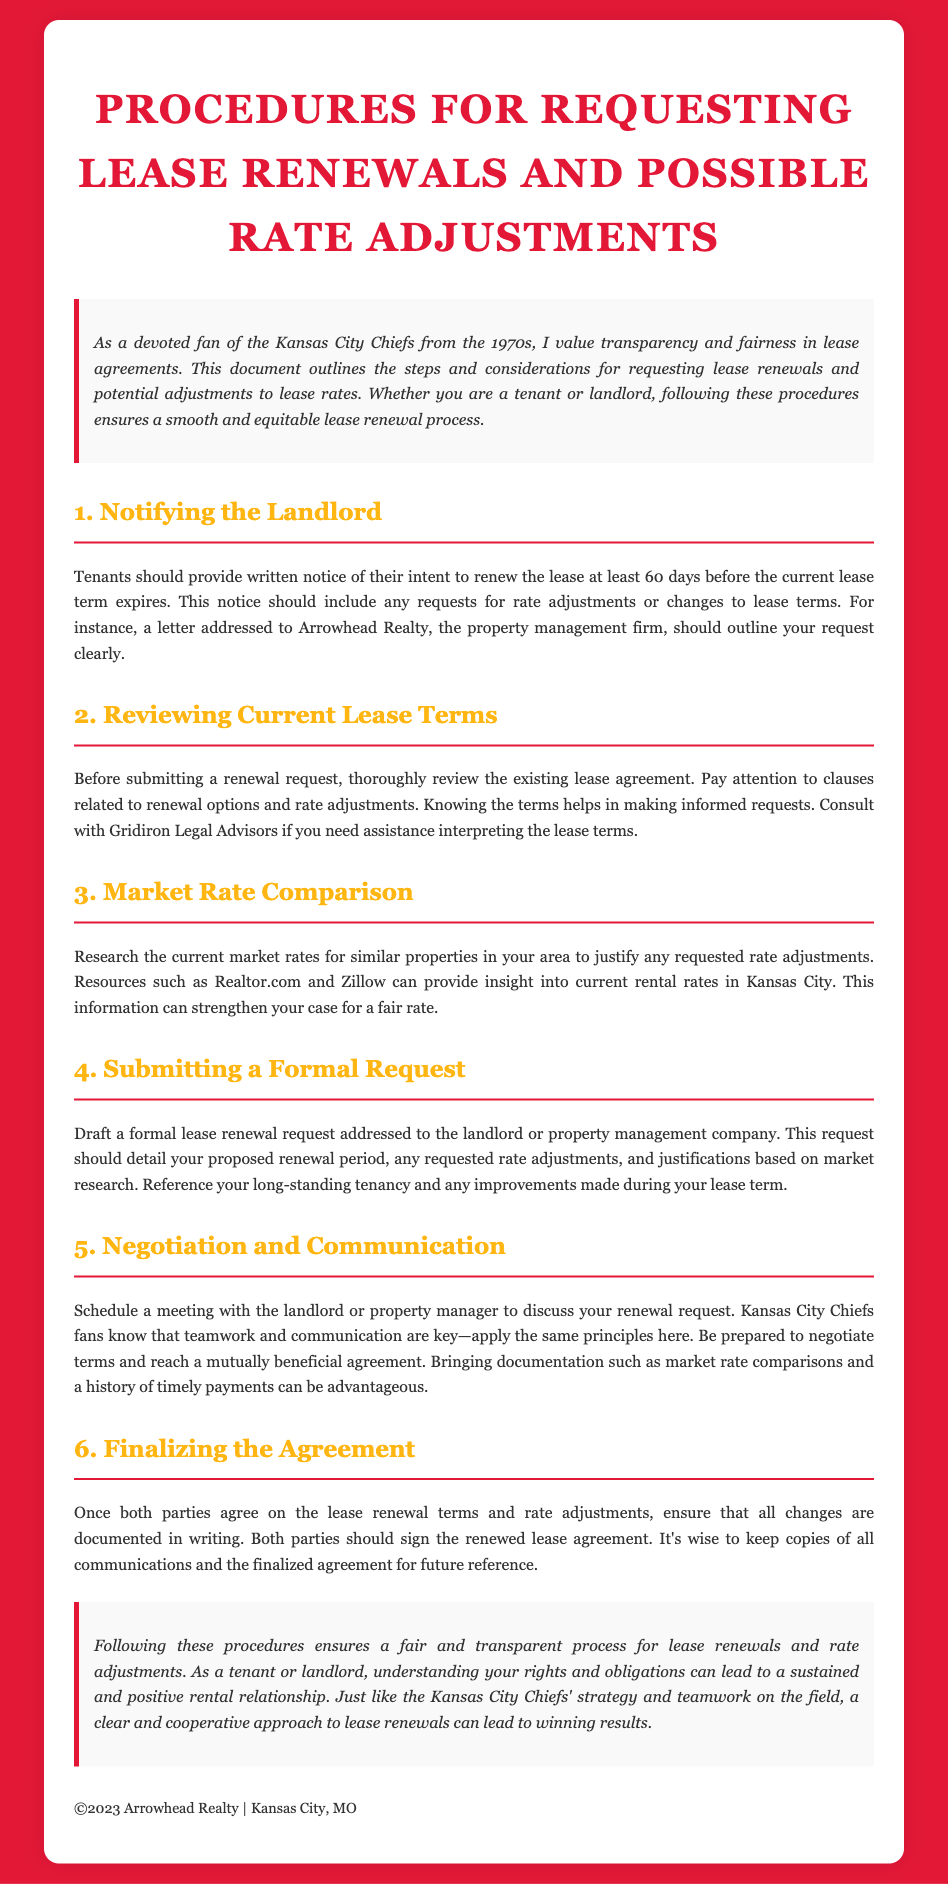What is the written notice period for lease renewal? Tenants must provide written notice of their intent to renew at least 60 days before the lease expires.
Answer: 60 days Who should the renewal request be addressed to? The renewal request should be directed to Arrowhead Realty, the property management firm.
Answer: Arrowhead Realty What should be included in the renewal request? The formal lease renewal request should detail the proposed renewal period and any requested rate adjustments based on market research.
Answer: Proposed renewal period and rate adjustments What is a key step before submitting a renewal request? Reviewing the existing lease agreement thoroughly is essential before making any renewal requests.
Answer: Reviewing the existing lease agreement What is advised to bring to the negotiation meeting? Bringing documentation such as market rate comparisons and a history of timely payments can be advantageous during the negotiation.
Answer: Market rate comparisons and payment history What should happen once both parties agree on the terms? All changes to the lease renewal terms and rate adjustments must be documented in writing.
Answer: Documented in writing Who can tenants consult for help with lease terms? Tenants are advised to consult Gridiron Legal Advisors for assistance in interpreting the lease terms.
Answer: Gridiron Legal Advisors What market research sources are suggested? Resources like Realtor.com and Zillow are recommended for researching current market rates.
Answer: Realtor.com and Zillow 